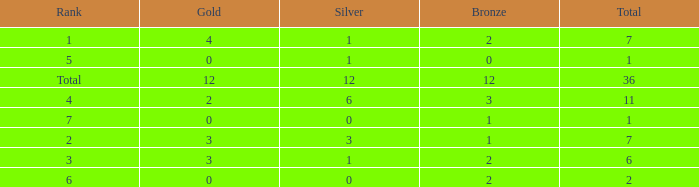What is the highest number of silver medals for a team with total less than 1? None. 